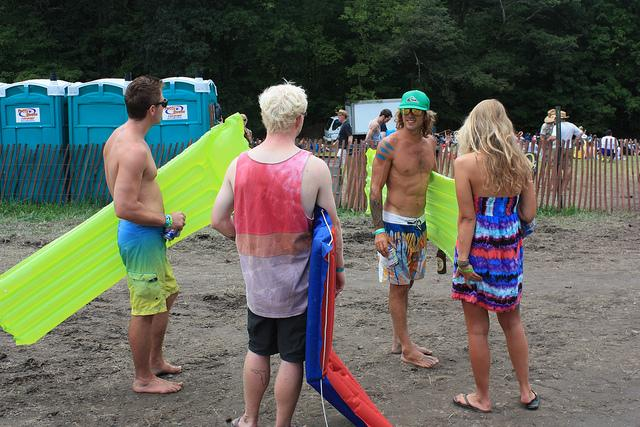Why is the guy's neck red?

Choices:
A) hair dye
B) makeup
C) blushing
D) sunburn sunburn 